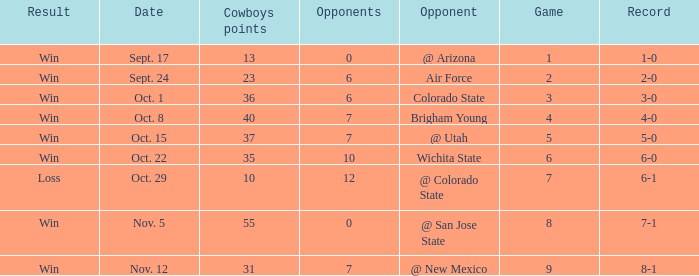What was the Cowboys' record for Nov. 5, 1966? 7-1. 